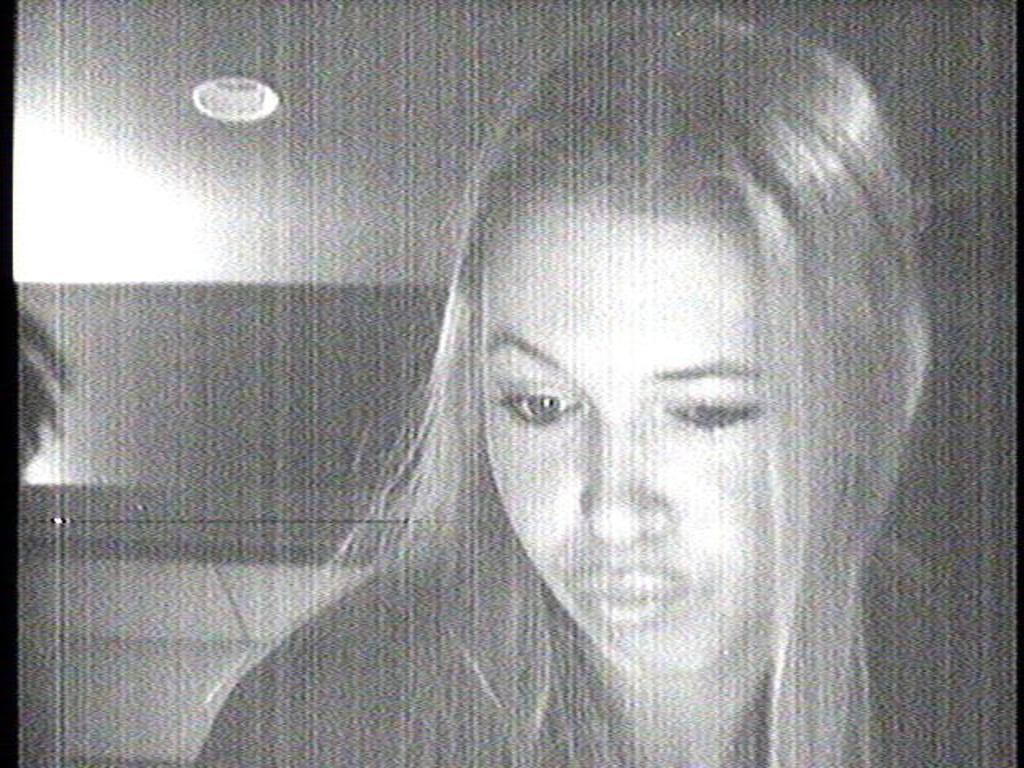Who is present in the image? There is a woman in the image. What can be seen in the background of the image? There is a wall, a ceiling, and a light in the background of the image. What is the color scheme of the image? The image is black and white. What type of ball is being used to mark the boundary in the image? There is no ball or boundary present in the image; it features a woman in a room with a wall, ceiling, and light. 